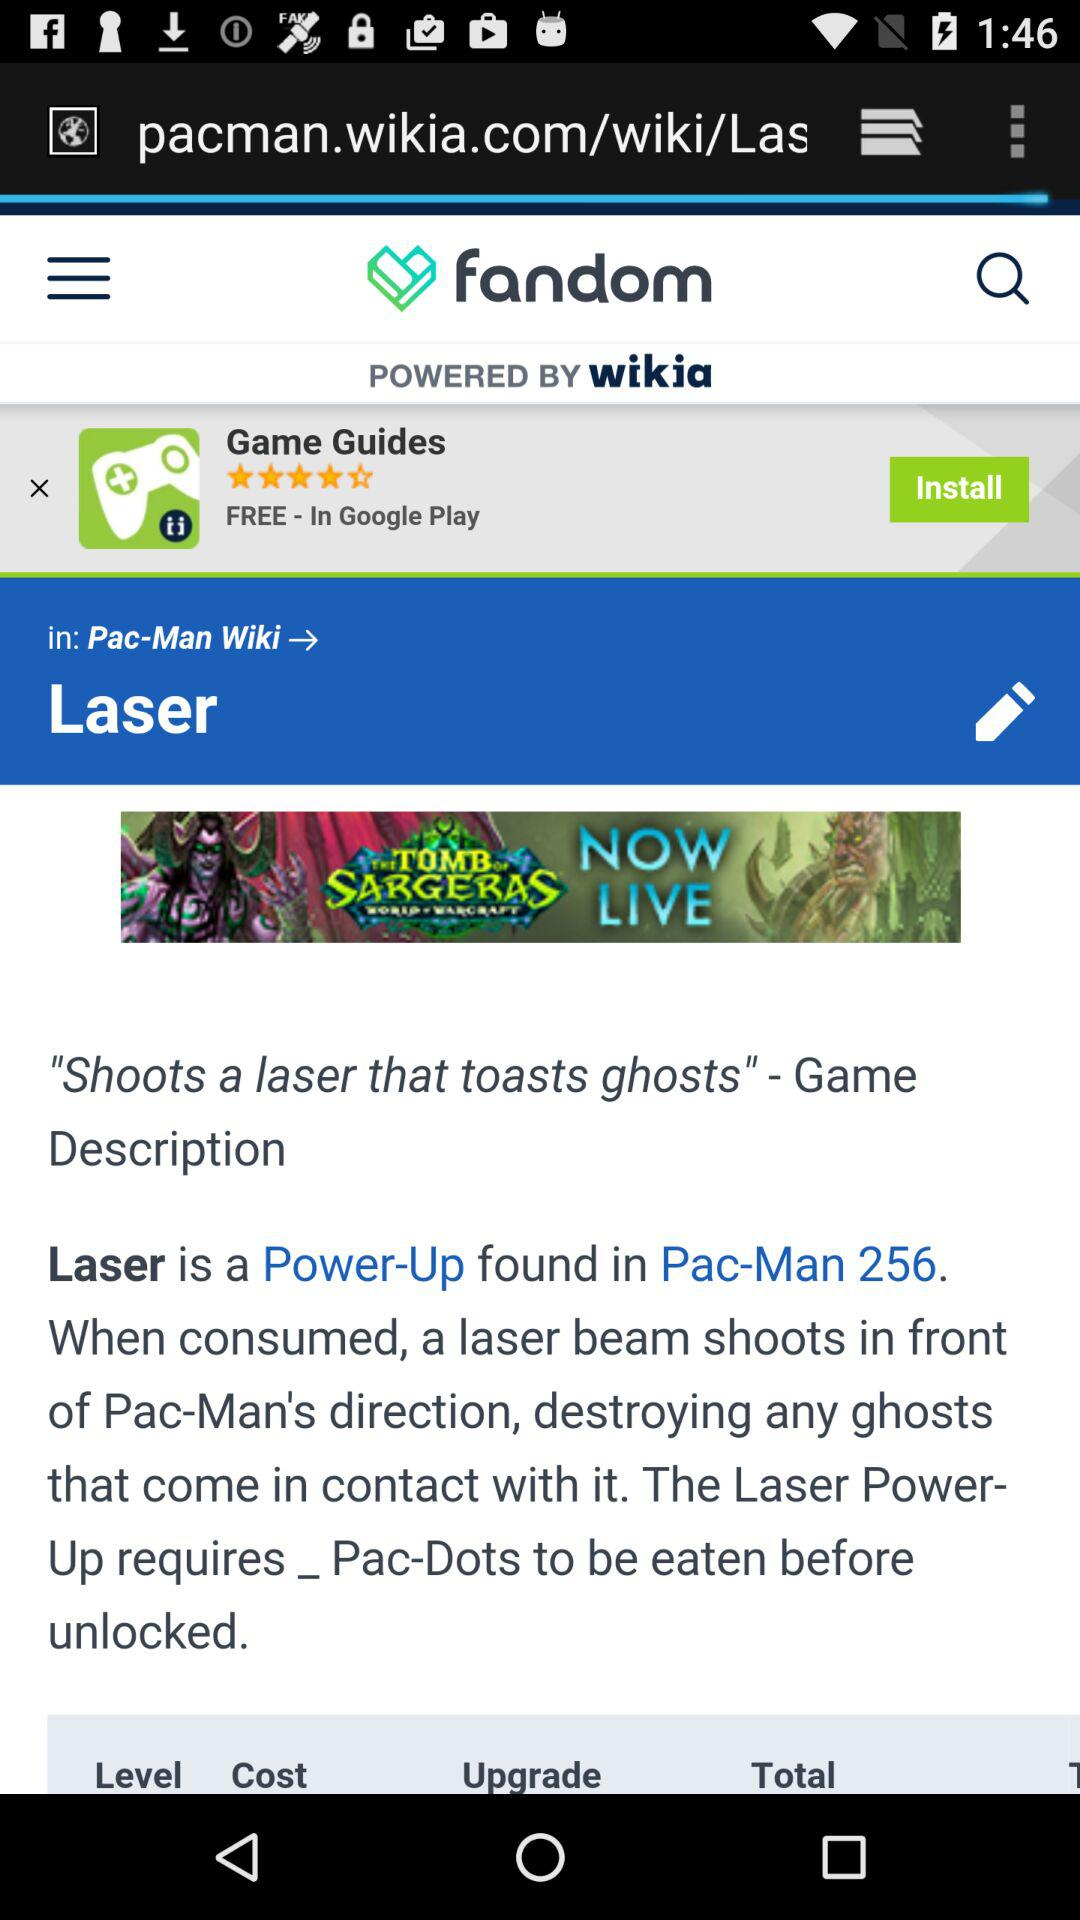What is the game description? The game description is "Shoots a laser that toasts ghosts". 